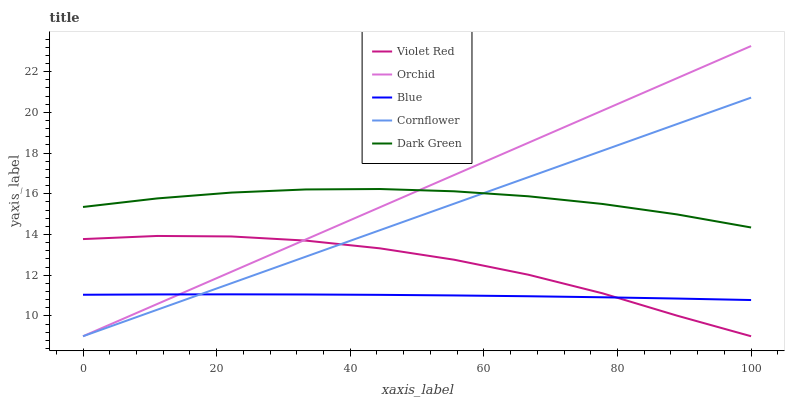Does Blue have the minimum area under the curve?
Answer yes or no. Yes. Does Orchid have the maximum area under the curve?
Answer yes or no. Yes. Does Cornflower have the minimum area under the curve?
Answer yes or no. No. Does Cornflower have the maximum area under the curve?
Answer yes or no. No. Is Orchid the smoothest?
Answer yes or no. Yes. Is Violet Red the roughest?
Answer yes or no. Yes. Is Cornflower the smoothest?
Answer yes or no. No. Is Cornflower the roughest?
Answer yes or no. No. Does Cornflower have the lowest value?
Answer yes or no. Yes. Does Dark Green have the lowest value?
Answer yes or no. No. Does Orchid have the highest value?
Answer yes or no. Yes. Does Cornflower have the highest value?
Answer yes or no. No. Is Blue less than Dark Green?
Answer yes or no. Yes. Is Dark Green greater than Blue?
Answer yes or no. Yes. Does Orchid intersect Blue?
Answer yes or no. Yes. Is Orchid less than Blue?
Answer yes or no. No. Is Orchid greater than Blue?
Answer yes or no. No. Does Blue intersect Dark Green?
Answer yes or no. No. 